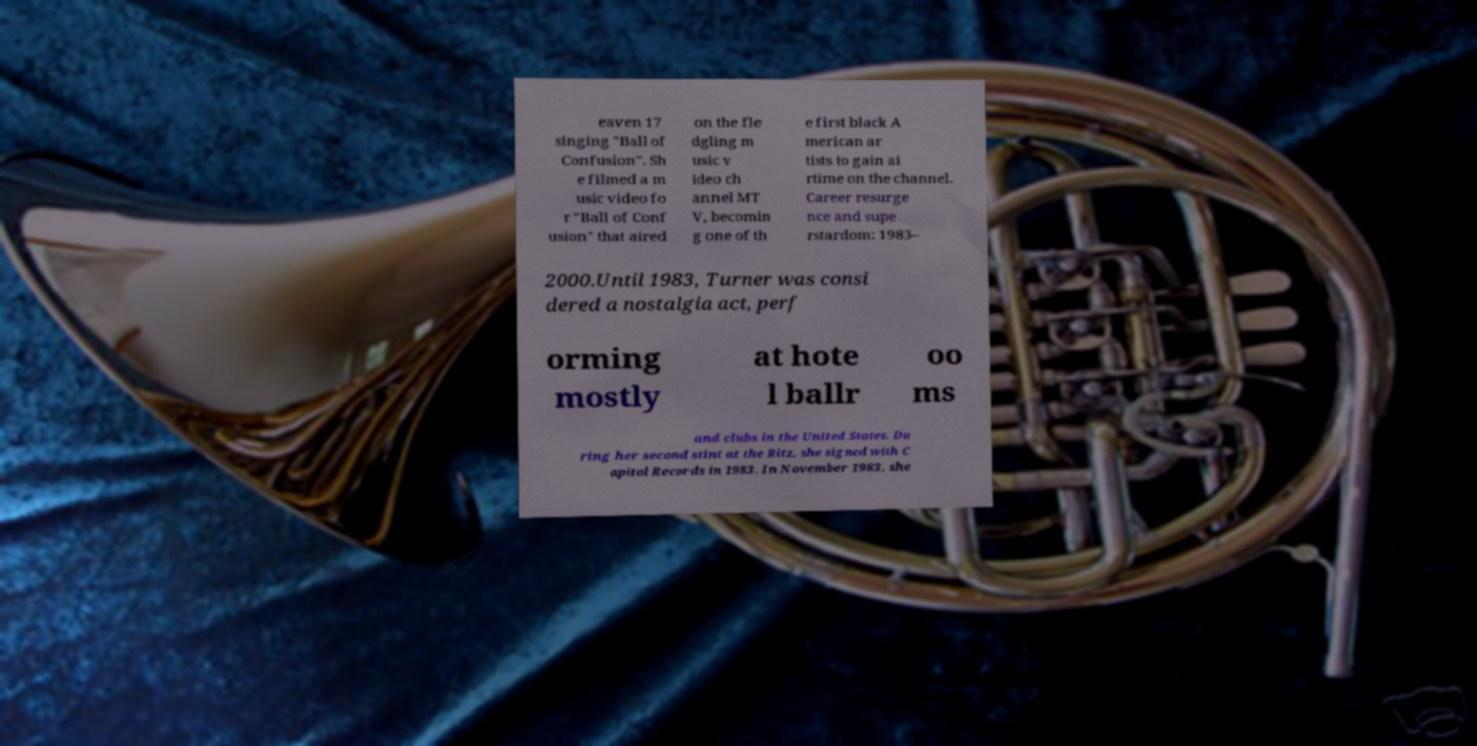Please read and relay the text visible in this image. What does it say? eaven 17 singing "Ball of Confusion". Sh e filmed a m usic video fo r "Ball of Conf usion" that aired on the fle dgling m usic v ideo ch annel MT V, becomin g one of th e first black A merican ar tists to gain ai rtime on the channel. Career resurge nce and supe rstardom: 1983– 2000.Until 1983, Turner was consi dered a nostalgia act, perf orming mostly at hote l ballr oo ms and clubs in the United States. Du ring her second stint at the Ritz, she signed with C apitol Records in 1983. In November 1983, she 